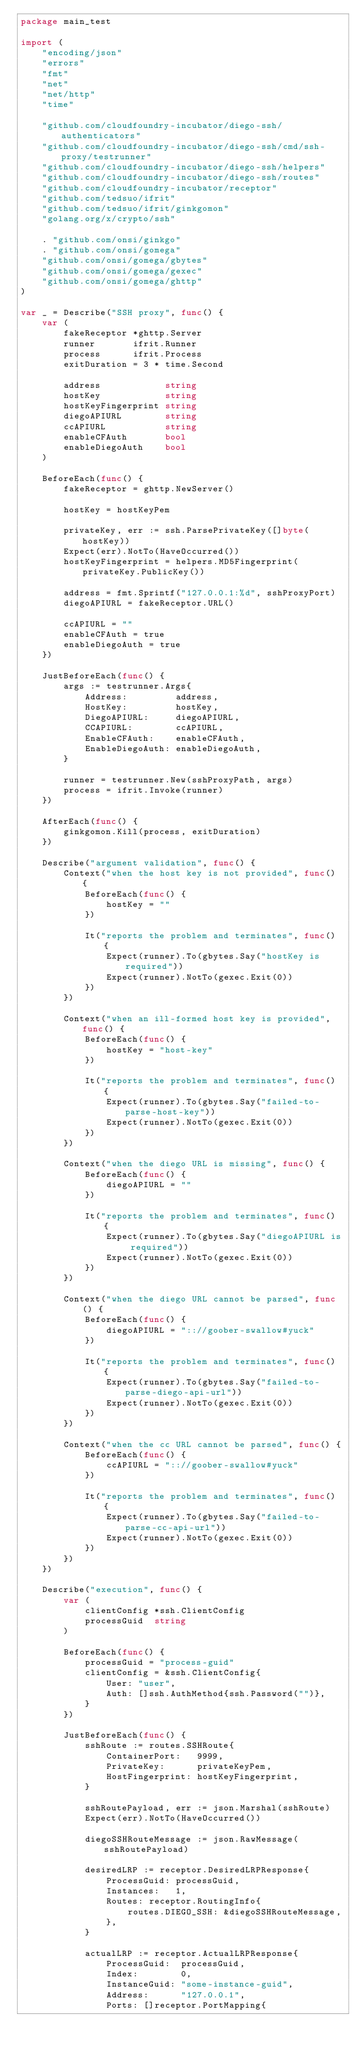<code> <loc_0><loc_0><loc_500><loc_500><_Go_>package main_test

import (
	"encoding/json"
	"errors"
	"fmt"
	"net"
	"net/http"
	"time"

	"github.com/cloudfoundry-incubator/diego-ssh/authenticators"
	"github.com/cloudfoundry-incubator/diego-ssh/cmd/ssh-proxy/testrunner"
	"github.com/cloudfoundry-incubator/diego-ssh/helpers"
	"github.com/cloudfoundry-incubator/diego-ssh/routes"
	"github.com/cloudfoundry-incubator/receptor"
	"github.com/tedsuo/ifrit"
	"github.com/tedsuo/ifrit/ginkgomon"
	"golang.org/x/crypto/ssh"

	. "github.com/onsi/ginkgo"
	. "github.com/onsi/gomega"
	"github.com/onsi/gomega/gbytes"
	"github.com/onsi/gomega/gexec"
	"github.com/onsi/gomega/ghttp"
)

var _ = Describe("SSH proxy", func() {
	var (
		fakeReceptor *ghttp.Server
		runner       ifrit.Runner
		process      ifrit.Process
		exitDuration = 3 * time.Second

		address            string
		hostKey            string
		hostKeyFingerprint string
		diegoAPIURL        string
		ccAPIURL           string
		enableCFAuth       bool
		enableDiegoAuth    bool
	)

	BeforeEach(func() {
		fakeReceptor = ghttp.NewServer()

		hostKey = hostKeyPem

		privateKey, err := ssh.ParsePrivateKey([]byte(hostKey))
		Expect(err).NotTo(HaveOccurred())
		hostKeyFingerprint = helpers.MD5Fingerprint(privateKey.PublicKey())

		address = fmt.Sprintf("127.0.0.1:%d", sshProxyPort)
		diegoAPIURL = fakeReceptor.URL()

		ccAPIURL = ""
		enableCFAuth = true
		enableDiegoAuth = true
	})

	JustBeforeEach(func() {
		args := testrunner.Args{
			Address:         address,
			HostKey:         hostKey,
			DiegoAPIURL:     diegoAPIURL,
			CCAPIURL:        ccAPIURL,
			EnableCFAuth:    enableCFAuth,
			EnableDiegoAuth: enableDiegoAuth,
		}

		runner = testrunner.New(sshProxyPath, args)
		process = ifrit.Invoke(runner)
	})

	AfterEach(func() {
		ginkgomon.Kill(process, exitDuration)
	})

	Describe("argument validation", func() {
		Context("when the host key is not provided", func() {
			BeforeEach(func() {
				hostKey = ""
			})

			It("reports the problem and terminates", func() {
				Expect(runner).To(gbytes.Say("hostKey is required"))
				Expect(runner).NotTo(gexec.Exit(0))
			})
		})

		Context("when an ill-formed host key is provided", func() {
			BeforeEach(func() {
				hostKey = "host-key"
			})

			It("reports the problem and terminates", func() {
				Expect(runner).To(gbytes.Say("failed-to-parse-host-key"))
				Expect(runner).NotTo(gexec.Exit(0))
			})
		})

		Context("when the diego URL is missing", func() {
			BeforeEach(func() {
				diegoAPIURL = ""
			})

			It("reports the problem and terminates", func() {
				Expect(runner).To(gbytes.Say("diegoAPIURL is required"))
				Expect(runner).NotTo(gexec.Exit(0))
			})
		})

		Context("when the diego URL cannot be parsed", func() {
			BeforeEach(func() {
				diegoAPIURL = ":://goober-swallow#yuck"
			})

			It("reports the problem and terminates", func() {
				Expect(runner).To(gbytes.Say("failed-to-parse-diego-api-url"))
				Expect(runner).NotTo(gexec.Exit(0))
			})
		})

		Context("when the cc URL cannot be parsed", func() {
			BeforeEach(func() {
				ccAPIURL = ":://goober-swallow#yuck"
			})

			It("reports the problem and terminates", func() {
				Expect(runner).To(gbytes.Say("failed-to-parse-cc-api-url"))
				Expect(runner).NotTo(gexec.Exit(0))
			})
		})
	})

	Describe("execution", func() {
		var (
			clientConfig *ssh.ClientConfig
			processGuid  string
		)

		BeforeEach(func() {
			processGuid = "process-guid"
			clientConfig = &ssh.ClientConfig{
				User: "user",
				Auth: []ssh.AuthMethod{ssh.Password("")},
			}
		})

		JustBeforeEach(func() {
			sshRoute := routes.SSHRoute{
				ContainerPort:   9999,
				PrivateKey:      privateKeyPem,
				HostFingerprint: hostKeyFingerprint,
			}

			sshRoutePayload, err := json.Marshal(sshRoute)
			Expect(err).NotTo(HaveOccurred())

			diegoSSHRouteMessage := json.RawMessage(sshRoutePayload)

			desiredLRP := receptor.DesiredLRPResponse{
				ProcessGuid: processGuid,
				Instances:   1,
				Routes: receptor.RoutingInfo{
					routes.DIEGO_SSH: &diegoSSHRouteMessage,
				},
			}

			actualLRP := receptor.ActualLRPResponse{
				ProcessGuid:  processGuid,
				Index:        0,
				InstanceGuid: "some-instance-guid",
				Address:      "127.0.0.1",
				Ports: []receptor.PortMapping{</code> 